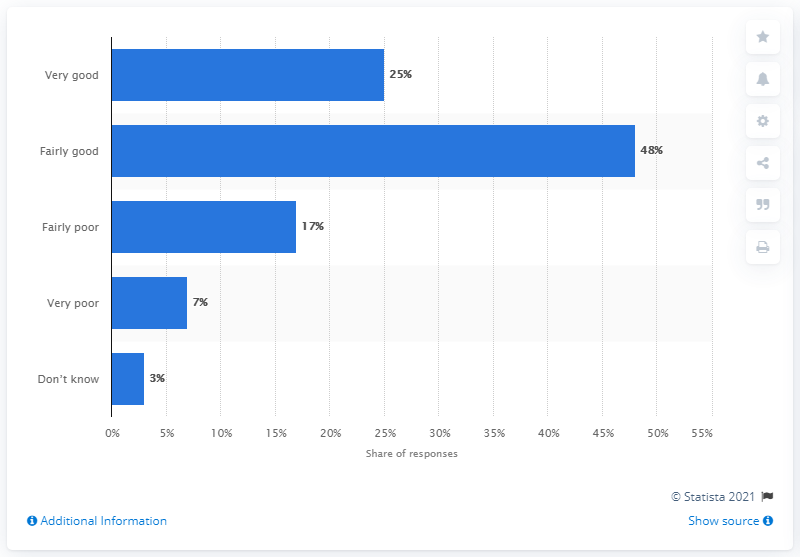Point out several critical features in this image. According to the survey results, 25% of the respondents rated their government's communication on the coronavirus outbreak as very good. 